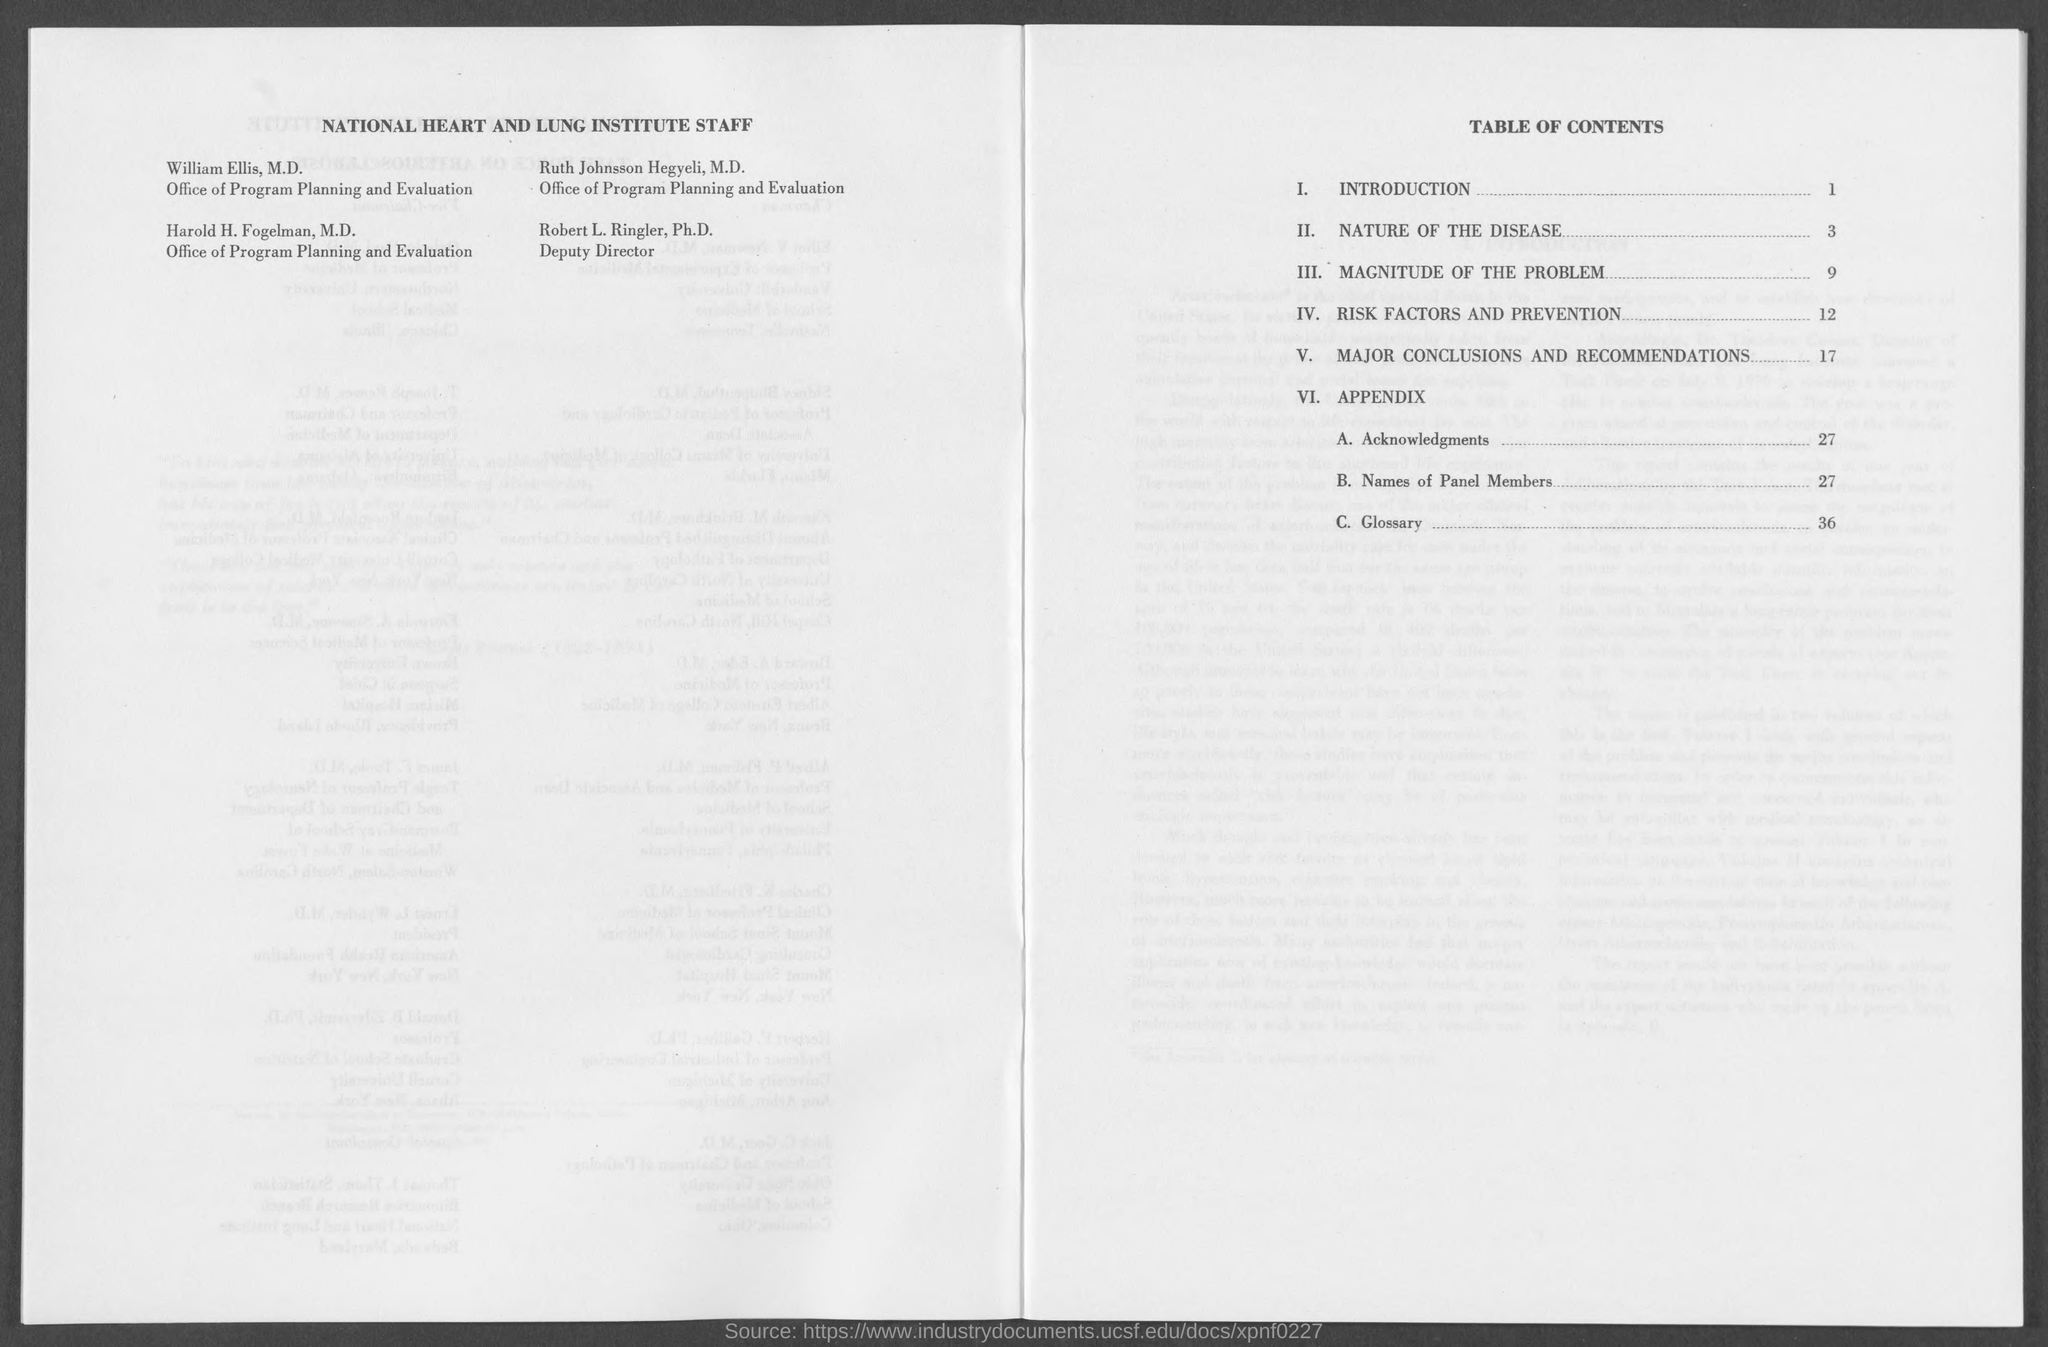List a handful of essential elements in this visual. Robert L. Ringler, Ph.D., is the Deputy Director. 